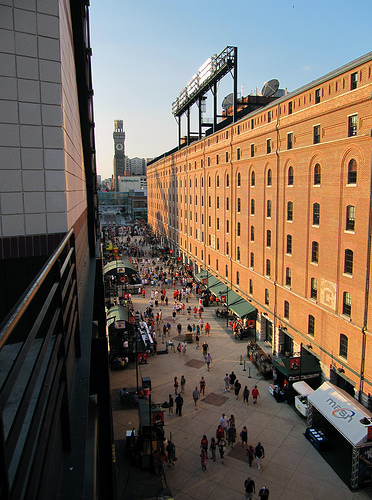<image>
Can you confirm if the lighting is on the sidewalk? No. The lighting is not positioned on the sidewalk. They may be near each other, but the lighting is not supported by or resting on top of the sidewalk. 